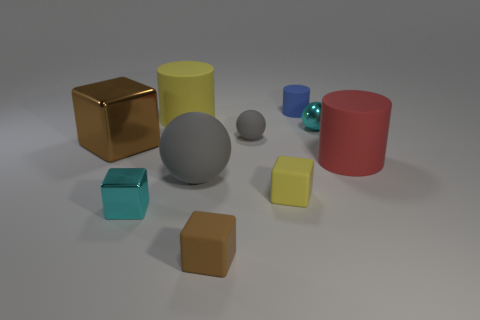What number of other objects are the same color as the shiny sphere?
Your answer should be compact. 1. How many other objects are the same material as the blue cylinder?
Offer a very short reply. 6. Does the cylinder that is to the left of the large gray matte ball have the same material as the small gray object?
Your answer should be very brief. Yes. Are there more cyan shiny things behind the blue thing than brown objects left of the big shiny thing?
Your response must be concise. No. How many things are either yellow matte objects behind the small gray matte thing or brown metal blocks?
Offer a terse response. 2. There is a small gray object that is made of the same material as the blue thing; what is its shape?
Your response must be concise. Sphere. Is there any other thing that is the same shape as the large gray thing?
Give a very brief answer. Yes. There is a tiny block that is to the left of the small gray rubber thing and on the right side of the cyan block; what is its color?
Offer a very short reply. Brown. How many cylinders are either small brown objects or big red objects?
Provide a succinct answer. 1. How many blue things have the same size as the brown matte block?
Offer a very short reply. 1. 